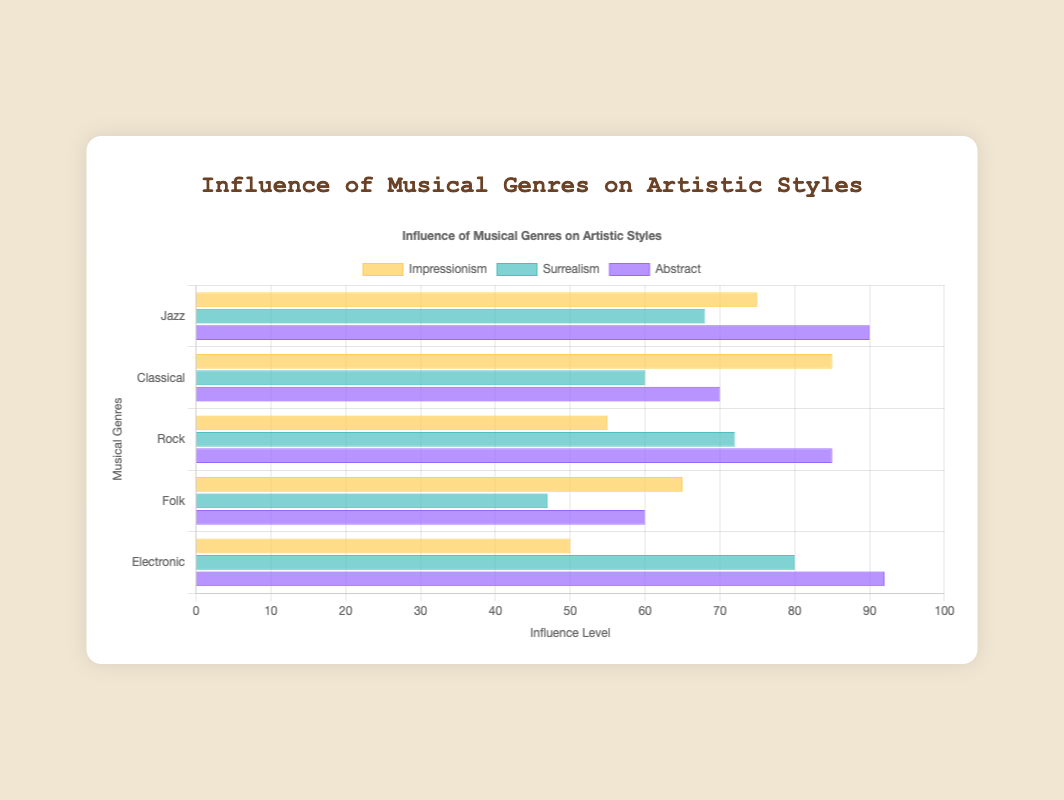What is the influence level of Jazz on Impressionism compared to Surrealism? To determine the influence level, look at the height/color of the bars for Jazz under Impressionism and Surrealism. Jazz influence on Impressionism is 75, and on Surrealism is 68.
Answer: 75 compared to 68 Which musical genre has the highest influence on Abstract art? Identify the highest bar in the Abstract dataset. Jazz has an influence of 90, Classical has 70, Rock has 85, Folk has 60, and Electronic has 92. The highest among these is Electronic.
Answer: Electronic How does the influence of Rock on Surrealism compare to its influence on Abstract? Compare the heights of the bars for Rock under Surrealism and Abstract. Rock's influence on Surrealism is 72, and on Abstract is 85.
Answer: 72 compared to 85 What is the average influence level of Classical music across all artistic styles? Sum the influence levels of Classical music for Impressionism (85), Surrealism (60), and Abstract (70), then divide by 3. (85 + 60 + 70) / 3 = 215 / 3 ≈ 71.67
Answer: 71.67 Which genre has the lowest influence on Impressionism? Identify the shortest bar in the Impressionism dataset. Jazz has 75, Classical has 85, Rock has 55, Folk has 65, and Electronic has 50. The lowest among these is Electronic.
Answer: Electronic Is there a genre that has the same influence level on two different artistic styles? Check for any influence levels that appear twice among the genres and styles. None of the values repeat for the genres across the styles, so there is no same influence level found.
Answer: No What is the total influence level of Jazz across all artistic styles? Sum the influence levels of Jazz for Impressionism (75), Surrealism (68), and Abstract (90). 75 + 68 + 90 = 233
Answer: 233 Which style is more influenced by Electronic music: Impressionism or Abstract? Compare the heights of the bars for Electronic music under Impressionism and Abstract. Impressionism has an influence of 50, while Abstract has an influence of 92. Abstract is more influenced.
Answer: Abstract What is the difference in influence levels of Folk music on Surrealism and Impressionism? Subtract the influence level of Folk music on Surrealism (47) from that on Impressionism (65). 65 - 47 = 18
Answer: 18 